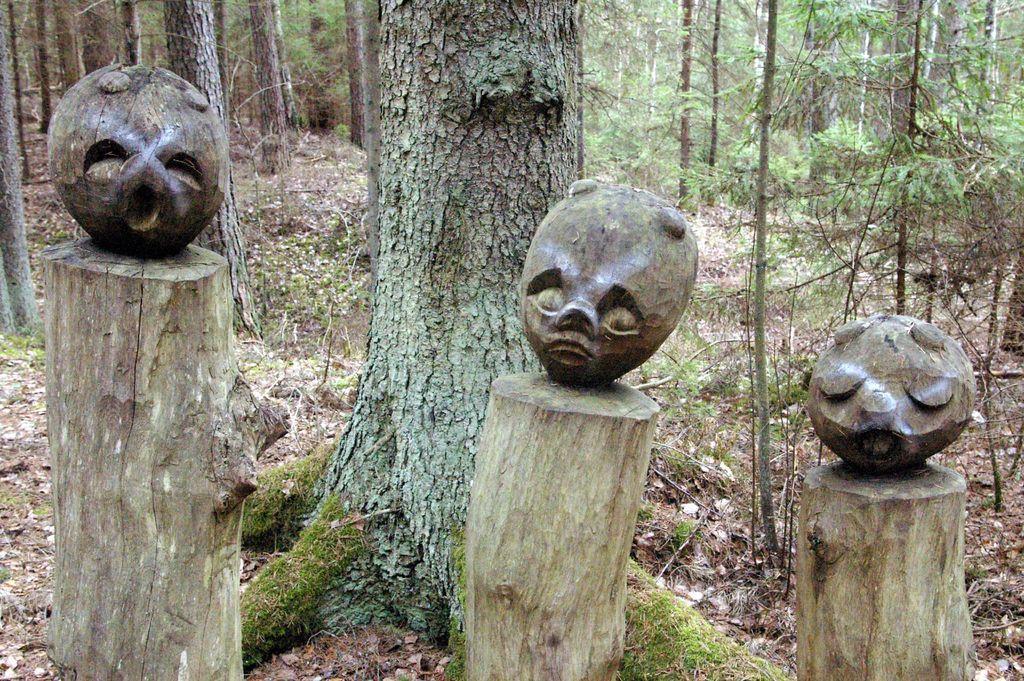Describe this image in one or two sentences. This picture is clicked outside. In the center we can see the trunk of a tree and we can see some wooden objects seems to be the wooden sculptures. In the background we can see the trees, plants and some other objects. 